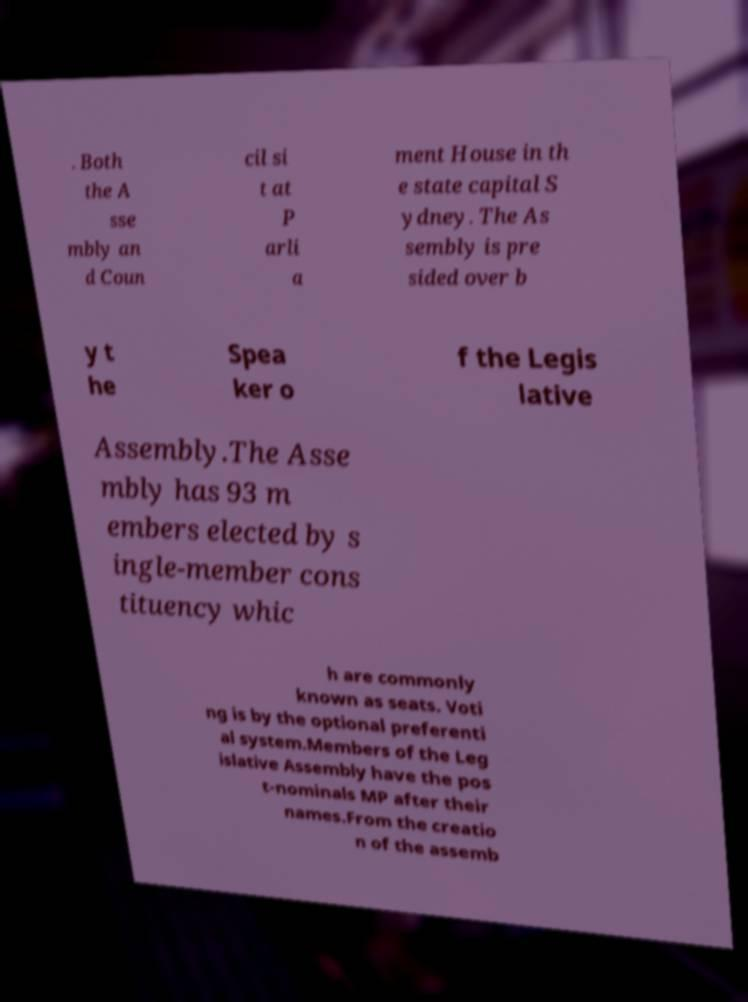There's text embedded in this image that I need extracted. Can you transcribe it verbatim? . Both the A sse mbly an d Coun cil si t at P arli a ment House in th e state capital S ydney. The As sembly is pre sided over b y t he Spea ker o f the Legis lative Assembly.The Asse mbly has 93 m embers elected by s ingle-member cons tituency whic h are commonly known as seats. Voti ng is by the optional preferenti al system.Members of the Leg islative Assembly have the pos t-nominals MP after their names.From the creatio n of the assemb 